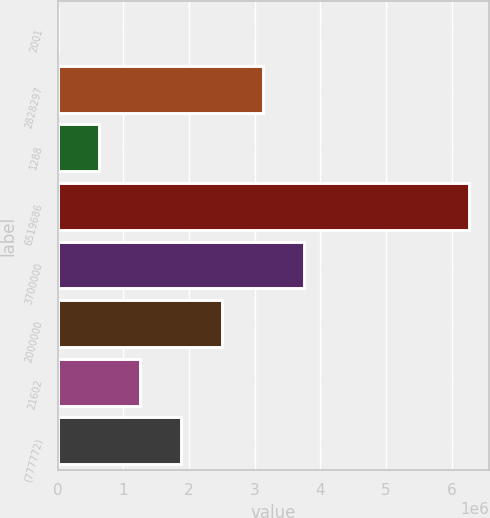<chart> <loc_0><loc_0><loc_500><loc_500><bar_chart><fcel>2001<fcel>2828297<fcel>1288<fcel>6519686<fcel>3700000<fcel>2000000<fcel>21602<fcel>(777772)<nl><fcel>2002<fcel>3.13129e+06<fcel>627860<fcel>6.26058e+06<fcel>3.75715e+06<fcel>2.50544e+06<fcel>1.25372e+06<fcel>1.87958e+06<nl></chart> 